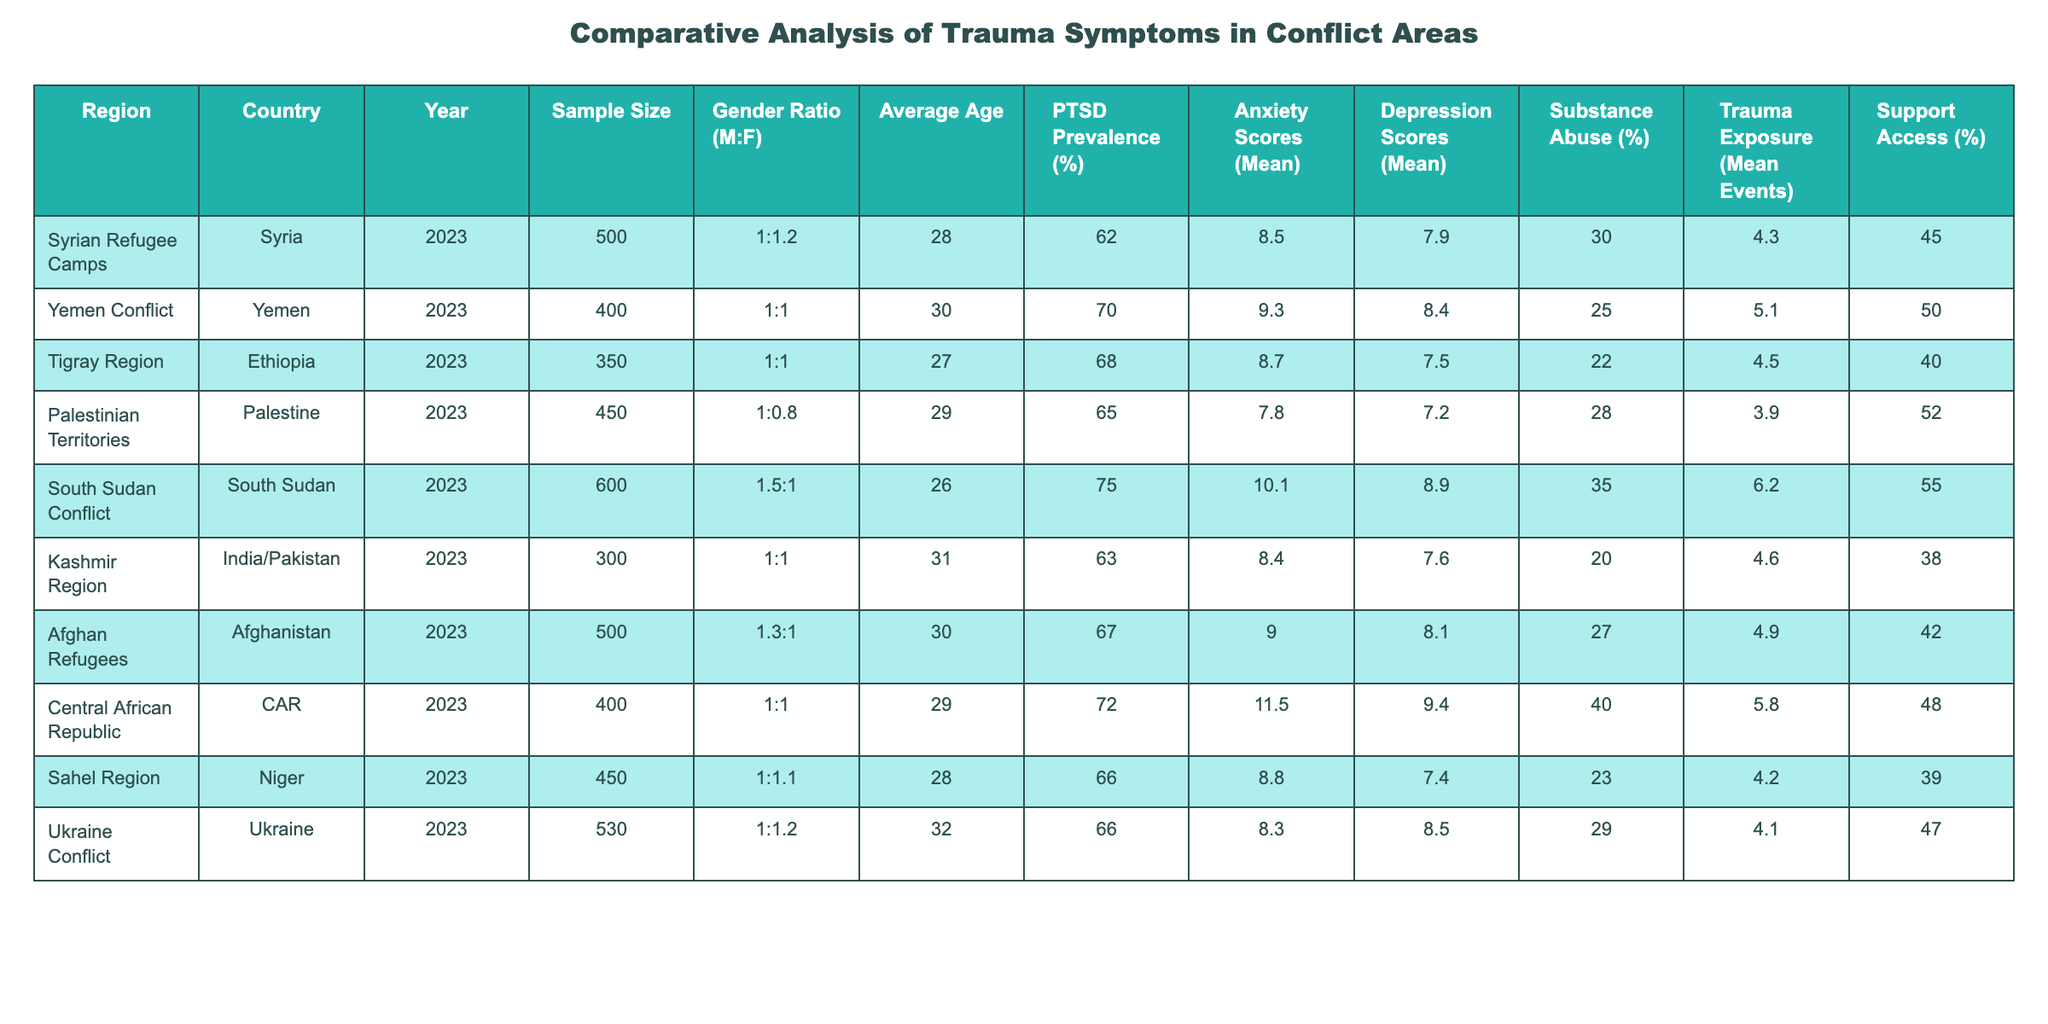What is the PTSD prevalence in the South Sudan Conflict? The table shows the PTSD prevalence specifically for South Sudan Conflict as 75%.
Answer: 75% How many trauma events did individuals in the Central African Republic report on average? The average trauma exposure recorded for individuals in the Central African Republic is 5.8 events as noted in the table.
Answer: 5.8 Which region has the highest reported substance abuse percentage? Reviewing the table, the Central African Republic has the highest reported substance abuse percentage at 40%.
Answer: 40% What is the average age of participants in the Afghan Refugees group? The table states that the average age of participants in the Afghan Refugees group is 30 years.
Answer: 30 Is the PTSD prevalence in the Syrian Refugee Camps higher than in the Palestine region? Comparing the table, the PTSD prevalence in Syrian Refugee Camps is 62% and in Palestine it is 65%, so it is false that Syria has a higher prevalence.
Answer: No What is the average depression score for individuals in the Yemen Conflict and how does it compare to those in Kashmire Region? The average depression score for the Yemen Conflict is 8.4, whereas for the Kashmir Region, it is 7.6. Therefore, Yemen Conflict has a higher average depression score by 0.8.
Answer: Yemen Conflict is higher by 0.8 What is the gender ratio in the Tigray Region and how does it compare to the South Sudan Conflict? The gender ratio for the Tigray Region is 1:1, while for South Sudan Conflict it is 1.5:1. The South Sudan Conflict has a higher male ratio compared to Tigray.
Answer: South Sudan has a higher male ratio How many regions reported a PTSD prevalence of 70% or higher? The table shows that there are three regions with PTSD prevalence of 70% or higher: Yemen (70%), South Sudan (75%), and CAR (72%). Therefore, the count is three.
Answer: Three What is the average anxiety score for the regions listed in the table? The average anxiety scores are: Syria (8.5), Yemen (9.3), Ethiopia (8.7), Palestine (7.8), South Sudan (8.9), Kashmir (7.6), Afghanistan (8.1), CAR (9.4), Niger (7.4), Ukraine (8.5). Summing these up and dividing by 10 gives an average anxiety score of 8.57.
Answer: 8.57 Does the Sahel Region have better support access compared to the Kashmir Region? The table shows support access for the Sahel Region at 39% and for Kashmir at 38%, indicating Sahel Region has slightly better support access.
Answer: Yes Calculate the difference in average depression scores between the South Sudan Conflict and Tigray Region. The average depression score for South Sudan is 8.9 and for Tigray is 7.5. The difference is 1.4, showing that South Sudan has a higher average depression score.
Answer: 1.4 